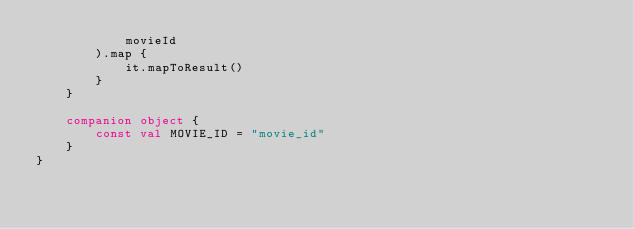<code> <loc_0><loc_0><loc_500><loc_500><_Kotlin_>            movieId
        ).map {
            it.mapToResult()
        }
    }

    companion object {
        const val MOVIE_ID = "movie_id"
    }
}</code> 